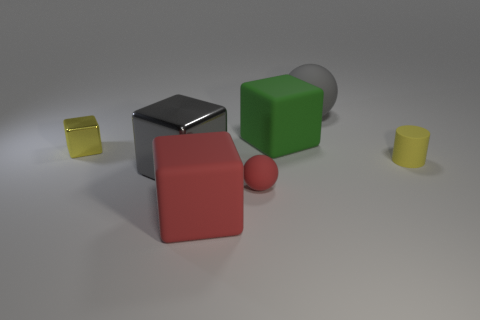What is the material of the big thing that is the same color as the large metal cube?
Give a very brief answer. Rubber. What is the color of the large metallic object that is the same shape as the small metal object?
Give a very brief answer. Gray. How many rubber objects are yellow cubes or purple cylinders?
Ensure brevity in your answer.  0. There is a red block in front of the matte sphere that is in front of the large rubber ball; is there a big gray shiny object on the left side of it?
Provide a succinct answer. Yes. What is the color of the matte cylinder?
Offer a terse response. Yellow. There is a metallic thing that is in front of the small yellow rubber cylinder; is it the same shape as the tiny yellow shiny object?
Offer a very short reply. Yes. What number of things are either small blue metallic spheres or matte spheres behind the large green matte thing?
Your response must be concise. 1. Are the ball that is in front of the large ball and the cylinder made of the same material?
Ensure brevity in your answer.  Yes. Is there anything else that is the same size as the red cube?
Offer a very short reply. Yes. What material is the object on the left side of the metallic cube that is to the right of the tiny yellow metallic object made of?
Offer a very short reply. Metal. 